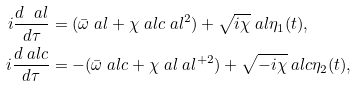<formula> <loc_0><loc_0><loc_500><loc_500>i \frac { d \ a l } { d \tau } & = ( \bar { \omega } \ a l + \chi \ a l c \ a l ^ { 2 } ) + \sqrt { i \chi } \ a l \eta _ { 1 } ( t ) , \\ i \frac { d \ a l c } { d \tau } & = - ( \bar { \omega } \ a l c + \chi \ a l \ a l ^ { + 2 } ) + \sqrt { - i \chi } \ a l c \eta _ { 2 } ( t ) ,</formula> 